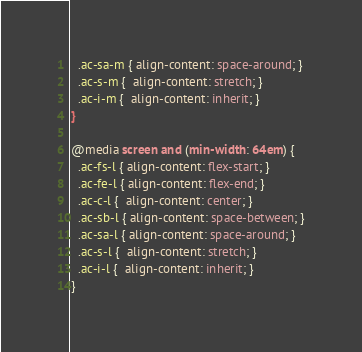<code> <loc_0><loc_0><loc_500><loc_500><_CSS_>  .ac-sa-m { align-content: space-around; }
  .ac-s-m {  align-content: stretch; }
  .ac-i-m {  align-content: inherit; }
}

@media screen and (min-width: 64em) {
  .ac-fs-l { align-content: flex-start; }
  .ac-fe-l { align-content: flex-end; }
  .ac-c-l {  align-content: center; }
  .ac-sb-l { align-content: space-between; }
  .ac-sa-l { align-content: space-around; }
  .ac-s-l {  align-content: stretch; }
  .ac-i-l {  align-content: inherit; }
}

</code> 